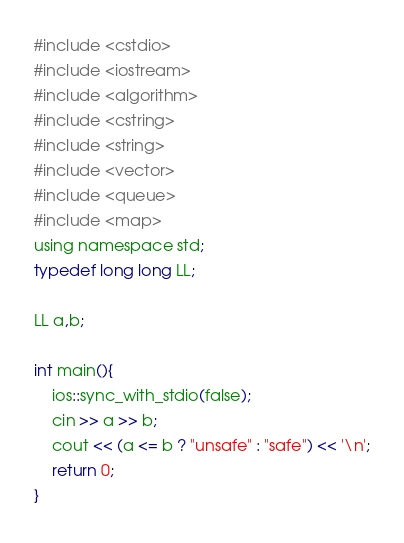Convert code to text. <code><loc_0><loc_0><loc_500><loc_500><_C_>#include <cstdio>
#include <iostream>
#include <algorithm>
#include <cstring>
#include <string>
#include <vector>
#include <queue>
#include <map>
using namespace std;
typedef long long LL;

LL a,b;

int main(){
	ios::sync_with_stdio(false);
	cin >> a >> b;
	cout << (a <= b ? "unsafe" : "safe") << '\n';
	return 0;
}</code> 